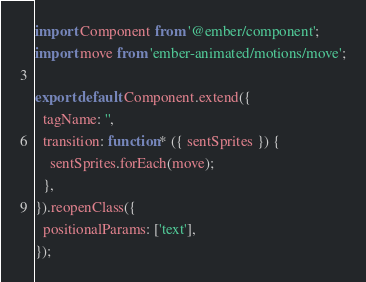Convert code to text. <code><loc_0><loc_0><loc_500><loc_500><_JavaScript_>import Component from '@ember/component';
import move from 'ember-animated/motions/move';

export default Component.extend({
  tagName: '',
  transition: function* ({ sentSprites }) {
    sentSprites.forEach(move);
  },
}).reopenClass({
  positionalParams: ['text'],
});
</code> 